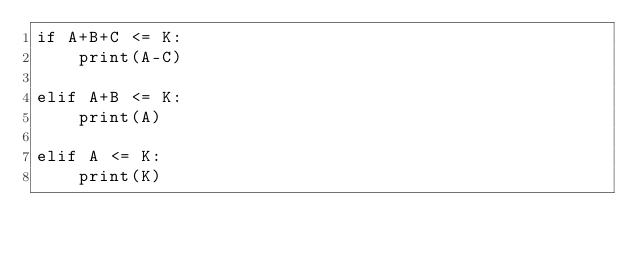Convert code to text. <code><loc_0><loc_0><loc_500><loc_500><_Python_>if A+B+C <= K:
    print(A-C)

elif A+B <= K:
    print(A)

elif A <= K:
    print(K)</code> 